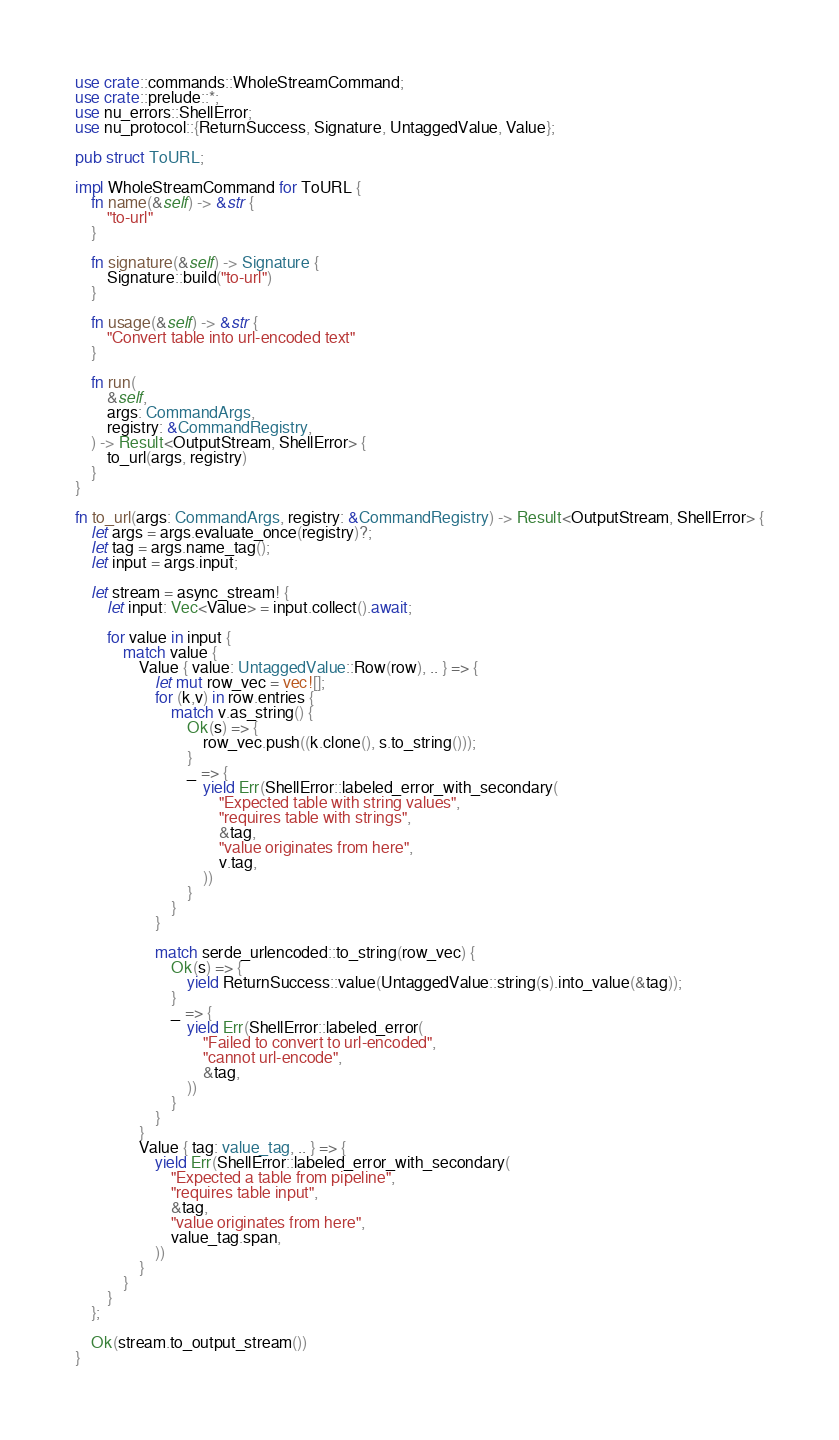<code> <loc_0><loc_0><loc_500><loc_500><_Rust_>use crate::commands::WholeStreamCommand;
use crate::prelude::*;
use nu_errors::ShellError;
use nu_protocol::{ReturnSuccess, Signature, UntaggedValue, Value};

pub struct ToURL;

impl WholeStreamCommand for ToURL {
    fn name(&self) -> &str {
        "to-url"
    }

    fn signature(&self) -> Signature {
        Signature::build("to-url")
    }

    fn usage(&self) -> &str {
        "Convert table into url-encoded text"
    }

    fn run(
        &self,
        args: CommandArgs,
        registry: &CommandRegistry,
    ) -> Result<OutputStream, ShellError> {
        to_url(args, registry)
    }
}

fn to_url(args: CommandArgs, registry: &CommandRegistry) -> Result<OutputStream, ShellError> {
    let args = args.evaluate_once(registry)?;
    let tag = args.name_tag();
    let input = args.input;

    let stream = async_stream! {
        let input: Vec<Value> = input.collect().await;

        for value in input {
            match value {
                Value { value: UntaggedValue::Row(row), .. } => {
                    let mut row_vec = vec![];
                    for (k,v) in row.entries {
                        match v.as_string() {
                            Ok(s) => {
                                row_vec.push((k.clone(), s.to_string()));
                            }
                            _ => {
                                yield Err(ShellError::labeled_error_with_secondary(
                                    "Expected table with string values",
                                    "requires table with strings",
                                    &tag,
                                    "value originates from here",
                                    v.tag,
                                ))
                            }
                        }
                    }

                    match serde_urlencoded::to_string(row_vec) {
                        Ok(s) => {
                            yield ReturnSuccess::value(UntaggedValue::string(s).into_value(&tag));
                        }
                        _ => {
                            yield Err(ShellError::labeled_error(
                                "Failed to convert to url-encoded",
                                "cannot url-encode",
                                &tag,
                            ))
                        }
                    }
                }
                Value { tag: value_tag, .. } => {
                    yield Err(ShellError::labeled_error_with_secondary(
                        "Expected a table from pipeline",
                        "requires table input",
                        &tag,
                        "value originates from here",
                        value_tag.span,
                    ))
                }
            }
        }
    };

    Ok(stream.to_output_stream())
}
</code> 